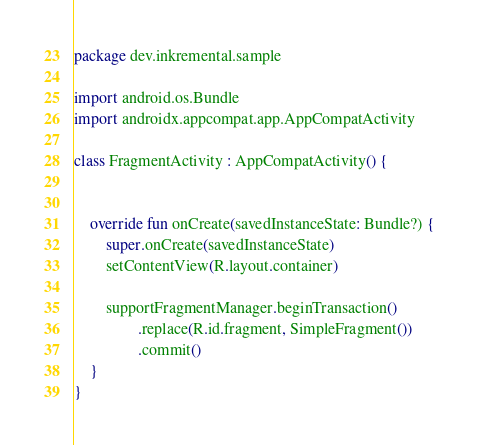<code> <loc_0><loc_0><loc_500><loc_500><_Kotlin_>package dev.inkremental.sample

import android.os.Bundle
import androidx.appcompat.app.AppCompatActivity

class FragmentActivity : AppCompatActivity() {


    override fun onCreate(savedInstanceState: Bundle?) {
        super.onCreate(savedInstanceState)
        setContentView(R.layout.container)

        supportFragmentManager.beginTransaction()
                .replace(R.id.fragment, SimpleFragment())
                .commit()
    }
}</code> 